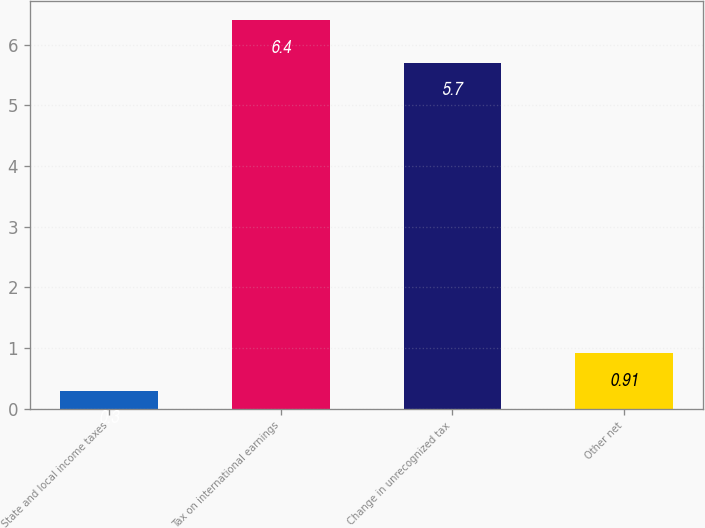<chart> <loc_0><loc_0><loc_500><loc_500><bar_chart><fcel>State and local income taxes<fcel>Tax on international earnings<fcel>Change in unrecognized tax<fcel>Other net<nl><fcel>0.3<fcel>6.4<fcel>5.7<fcel>0.91<nl></chart> 